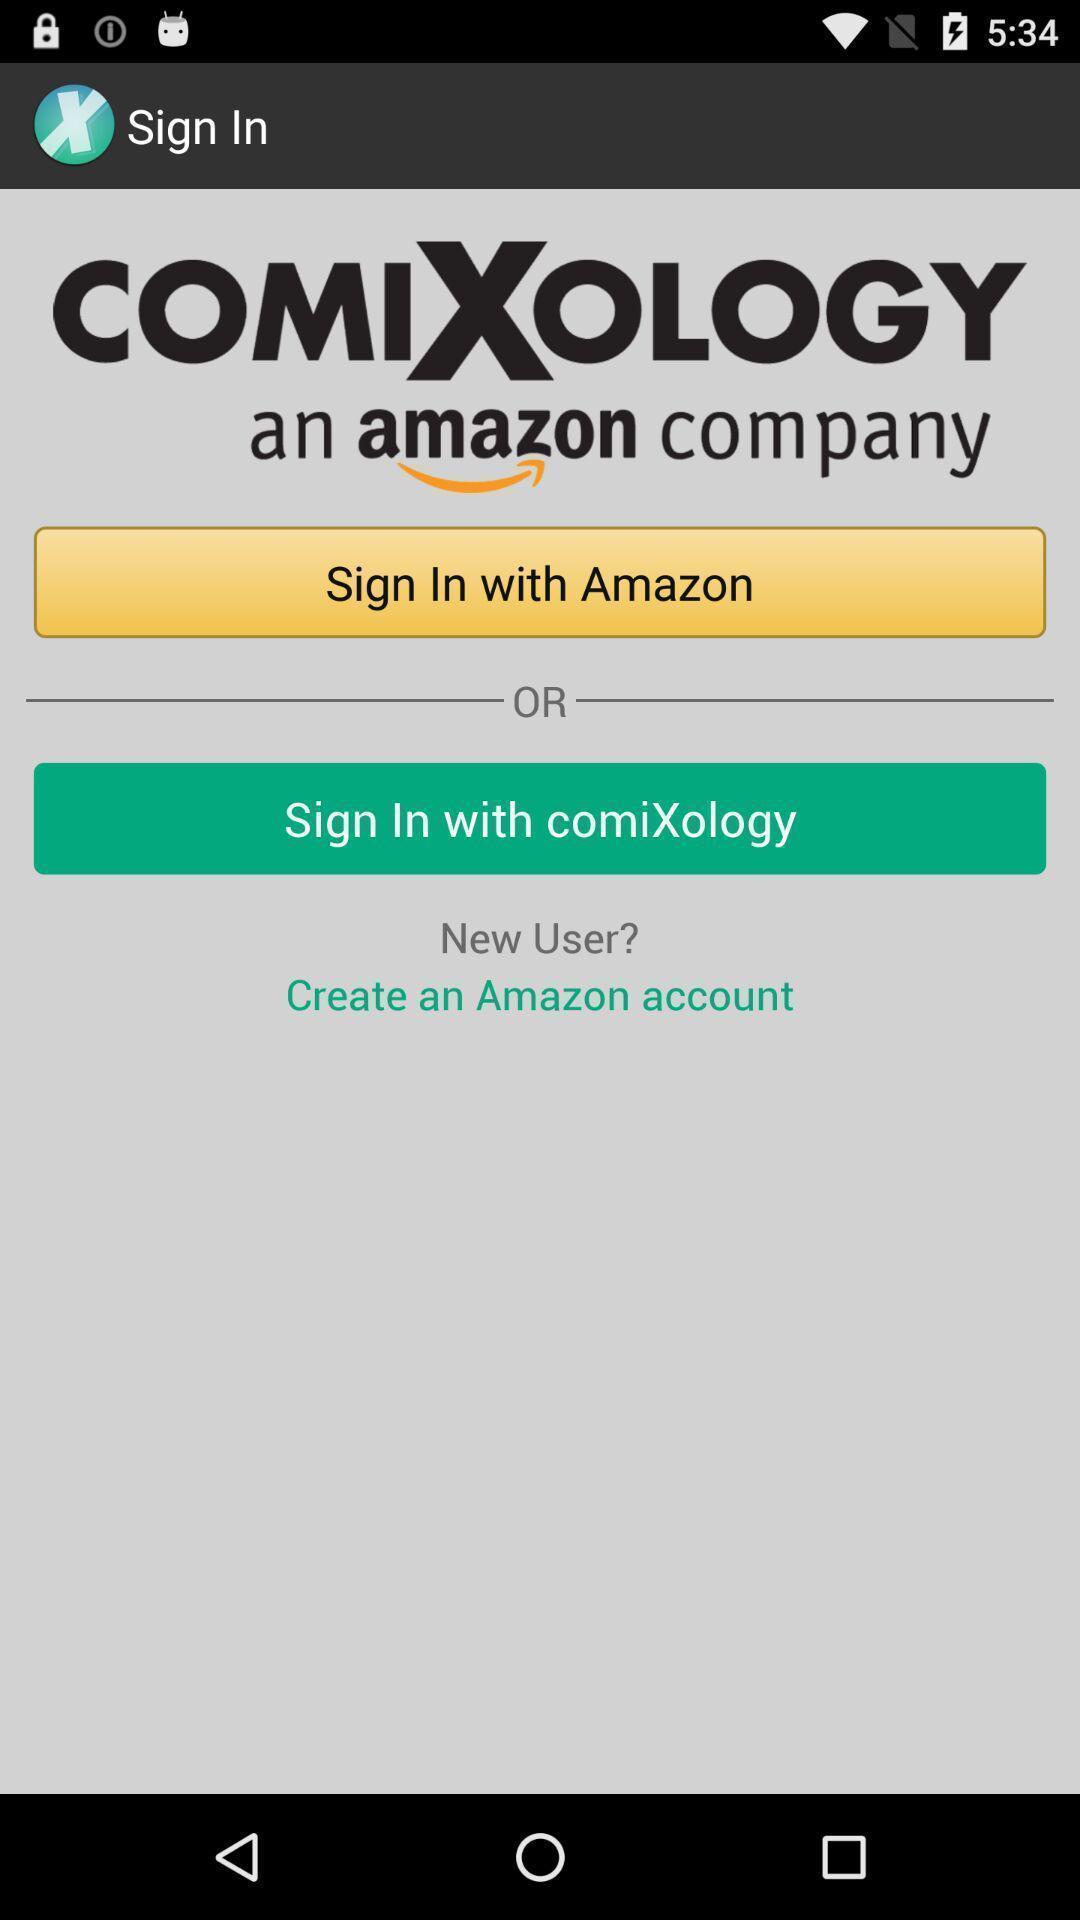Describe the content in this image. To sign in page for a book app. 